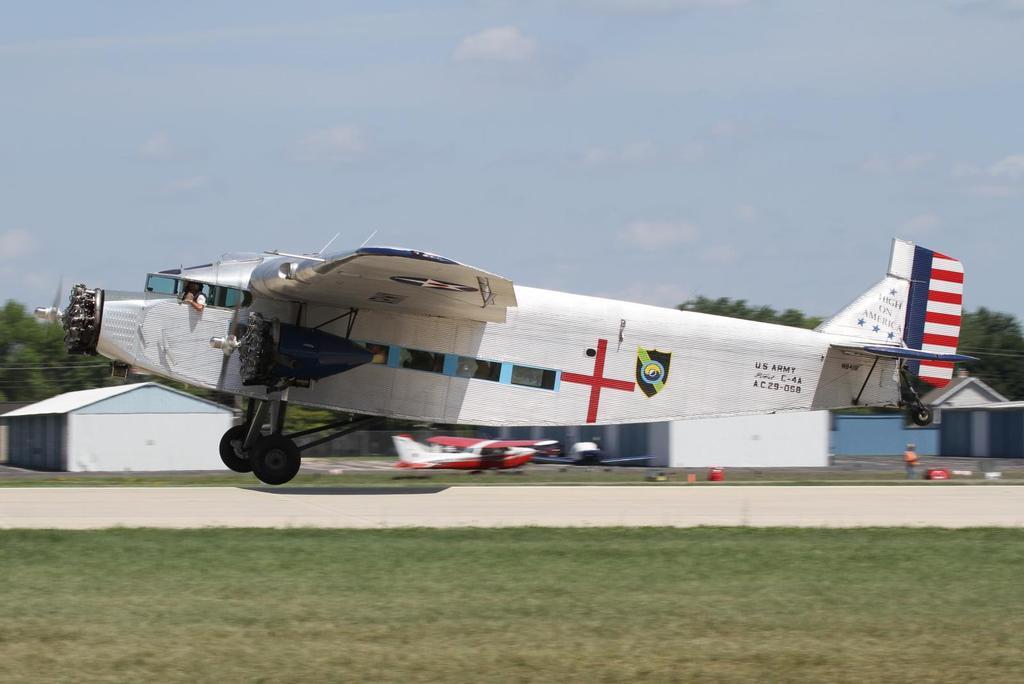Can you describe this image briefly? In this image we can see airplanes, a person and few objects on the ground, there are few buildings, trees, and the sky with clouds in the background. 